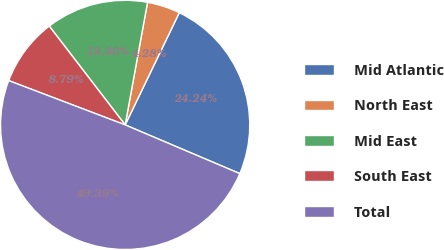Convert chart. <chart><loc_0><loc_0><loc_500><loc_500><pie_chart><fcel>Mid Atlantic<fcel>North East<fcel>Mid East<fcel>South East<fcel>Total<nl><fcel>24.24%<fcel>4.28%<fcel>13.3%<fcel>8.79%<fcel>49.39%<nl></chart> 